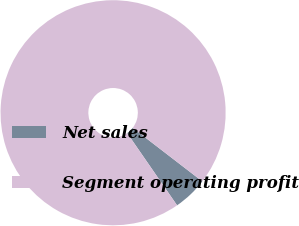Convert chart. <chart><loc_0><loc_0><loc_500><loc_500><pie_chart><fcel>Net sales<fcel>Segment operating profit<nl><fcel>4.94%<fcel>95.06%<nl></chart> 